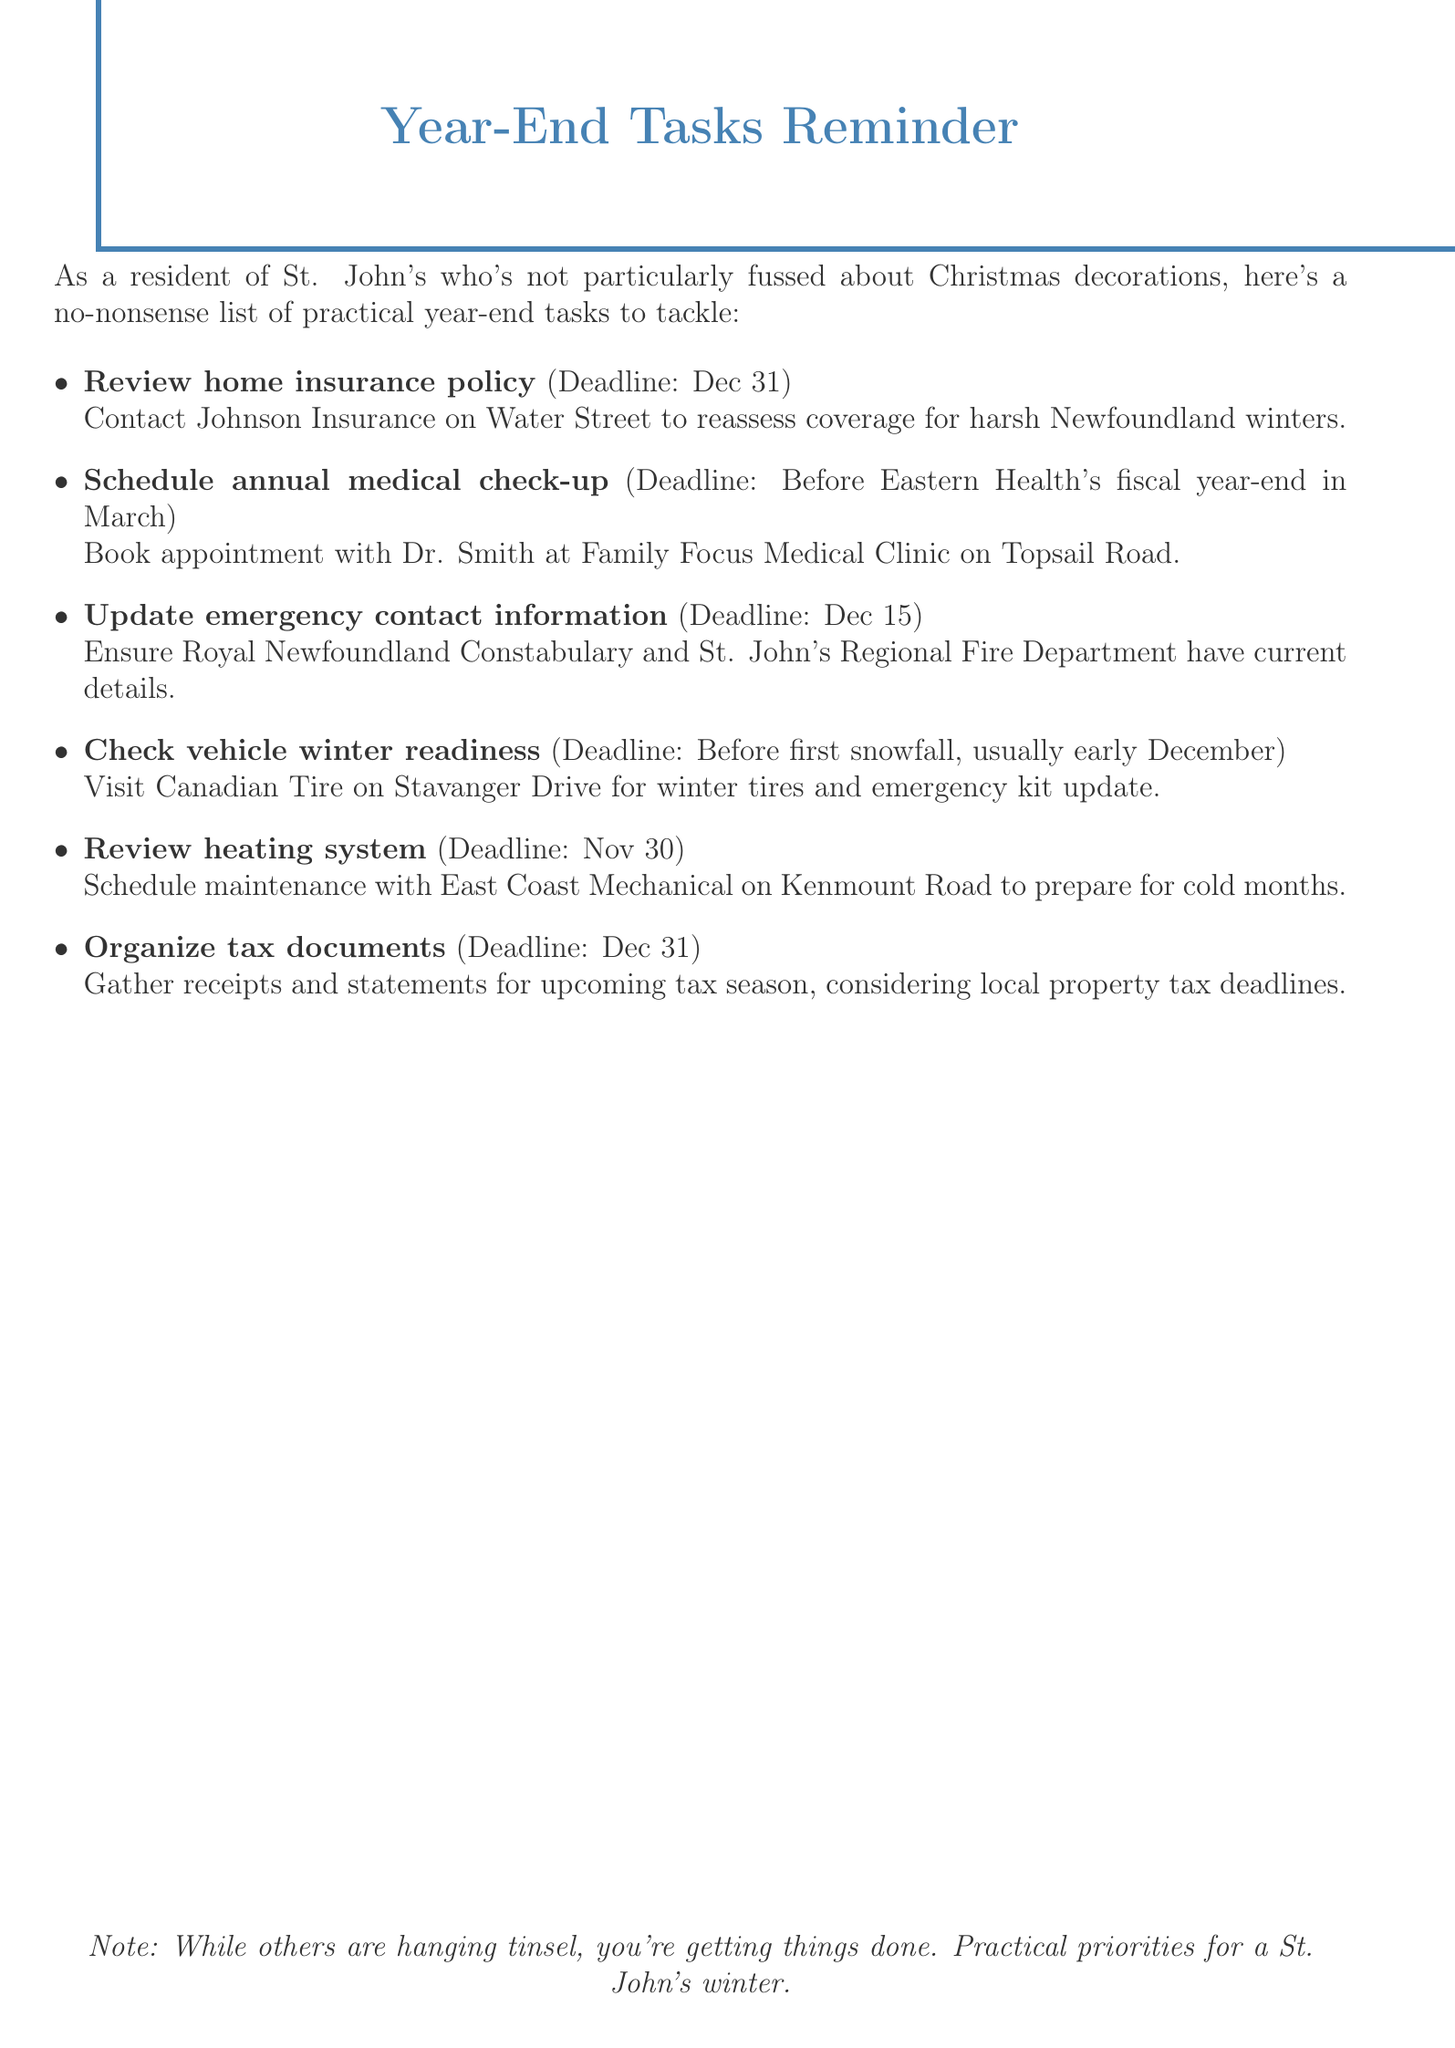What is the deadline for reviewing the home insurance policy? The deadline for reviewing the home insurance policy is stated as December 31.
Answer: December 31 Who should be contacted for the home insurance policy? The document specifies Johnson Insurance on Water Street as the contact for the home insurance policy.
Answer: Johnson Insurance When should the emergency contact information be updated? The deadline for updating emergency contact information is mentioned as December 15.
Answer: December 15 What is one task to prepare a vehicle for winter? The document advises visiting Canadian Tire on Stavanger Drive to check vehicle winter readiness.
Answer: Check vehicle winter readiness What type of maintenance should be scheduled with East Coast Mechanical? The document specifies that maintenance related to the heating system should be scheduled.
Answer: Heating system When is Eastern Health's fiscal year-end? The document states that the annual medical check-up should be scheduled before Eastern Health's fiscal year-end in March.
Answer: March How many year-end tasks are listed in the document? The document lists a total of six year-end tasks for residents.
Answer: Six What is the primary focus of this document? The document is a reminder of practical year-end tasks for St. John's residents, particularly for winter preparation.
Answer: Practical year-end tasks 